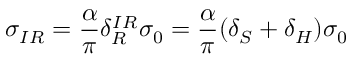Convert formula to latex. <formula><loc_0><loc_0><loc_500><loc_500>\sigma _ { I R } = \frac { \alpha } { \pi } \delta _ { R } ^ { I R } \sigma _ { 0 } = \frac { \alpha } { \pi } ( \delta _ { S } + \delta _ { H } ) \sigma _ { 0 }</formula> 